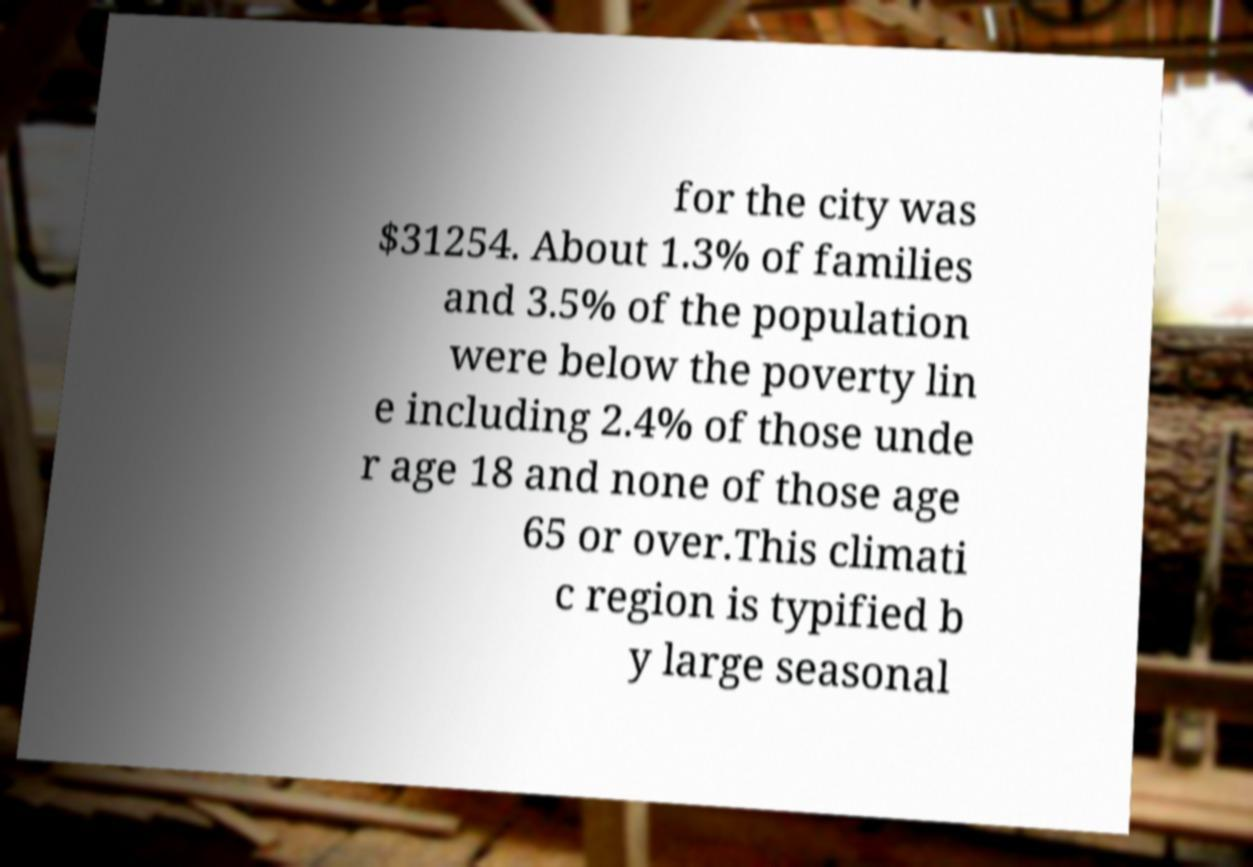Please identify and transcribe the text found in this image. for the city was $31254. About 1.3% of families and 3.5% of the population were below the poverty lin e including 2.4% of those unde r age 18 and none of those age 65 or over.This climati c region is typified b y large seasonal 